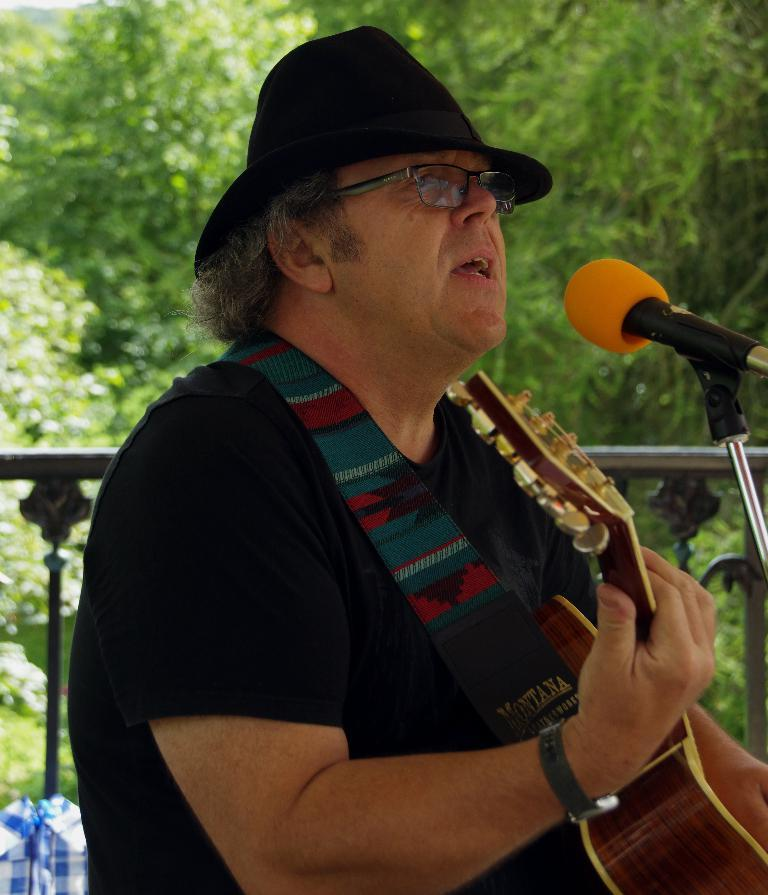What is the main subject of the image? There is a person in the center of the image. What is the person doing in the image? The person is playing a guitar. What object is in front of the person? There is a microphone in front of the person. What might the person be doing while playing the guitar? The person may be singing. What can be seen in the background of the image? There are trees visible in the background of the image. How many streams can be seen flowing through the person's eyes in the image? There are no streams flowing through the person's eyes in the image. What type of alarm is present in the image? There is no alarm present in the image. 